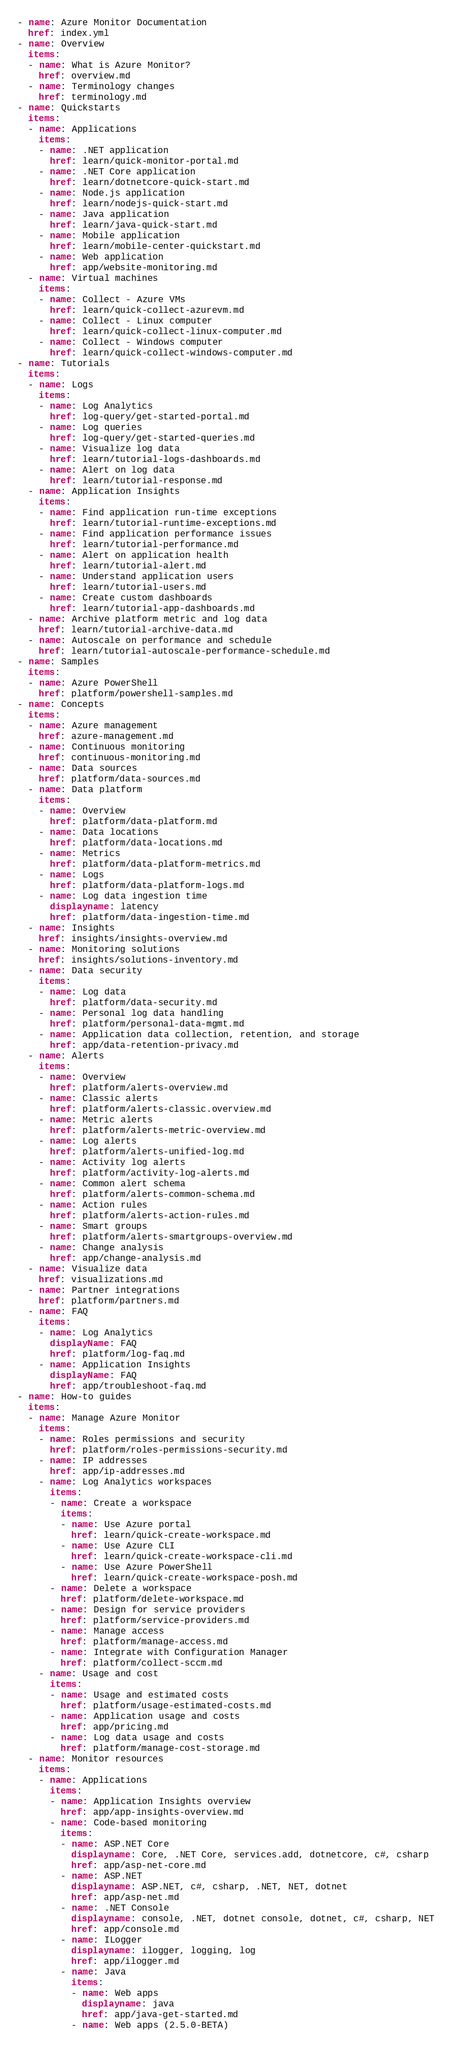Convert code to text. <code><loc_0><loc_0><loc_500><loc_500><_YAML_>- name: Azure Monitor Documentation
  href: index.yml
- name: Overview 
  items:
  - name: What is Azure Monitor?
    href: overview.md
  - name: Terminology changes
    href: terminology.md
- name: Quickstarts
  items:
  - name: Applications
    items:
    - name: .NET application
      href: learn/quick-monitor-portal.md
    - name: .NET Core application
      href: learn/dotnetcore-quick-start.md
    - name: Node.js application
      href: learn/nodejs-quick-start.md
    - name: Java application
      href: learn/java-quick-start.md
    - name: Mobile application
      href: learn/mobile-center-quickstart.md
    - name: Web application
      href: app/website-monitoring.md 
  - name: Virtual machines
    items:
    - name: Collect - Azure VMs
      href: learn/quick-collect-azurevm.md
    - name: Collect - Linux computer
      href: learn/quick-collect-linux-computer.md
    - name: Collect - Windows computer
      href: learn/quick-collect-windows-computer.md
- name: Tutorials
  items:
  - name: Logs
    items: 
    - name: Log Analytics
      href: log-query/get-started-portal.md
    - name: Log queries
      href: log-query/get-started-queries.md
    - name: Visualize log data
      href: learn/tutorial-logs-dashboards.md
    - name: Alert on log data
      href: learn/tutorial-response.md
  - name: Application Insights
    items:  
    - name: Find application run-time exceptions
      href: learn/tutorial-runtime-exceptions.md
    - name: Find application performance issues
      href: learn/tutorial-performance.md
    - name: Alert on application health
      href: learn/tutorial-alert.md
    - name: Understand application users
      href: learn/tutorial-users.md
    - name: Create custom dashboards
      href: learn/tutorial-app-dashboards.md
  - name: Archive platform metric and log data 
    href: learn/tutorial-archive-data.md
  - name: Autoscale on performance and schedule
    href: learn/tutorial-autoscale-performance-schedule.md
- name: Samples
  items:
  - name: Azure PowerShell
    href: platform/powershell-samples.md
- name: Concepts
  items:
  - name: Azure management
    href: azure-management.md
  - name: Continuous monitoring
    href: continuous-monitoring.md
  - name: Data sources
    href: platform/data-sources.md
  - name: Data platform
    items:
    - name: Overview
      href: platform/data-platform.md
    - name: Data locations
      href: platform/data-locations.md
    - name: Metrics
      href: platform/data-platform-metrics.md
    - name: Logs
      href: platform/data-platform-logs.md
    - name: Log data ingestion time
      displayname: latency
      href: platform/data-ingestion-time.md         
  - name: Insights
    href: insights/insights-overview.md
  - name: Monitoring solutions
    href: insights/solutions-inventory.md
  - name: Data security
    items:
    - name: Log data
      href: platform/data-security.md
    - name: Personal log data handling
      href: platform/personal-data-mgmt.md
    - name: Application data collection, retention, and storage
      href: app/data-retention-privacy.md
  - name: Alerts
    items:
    - name: Overview 
      href: platform/alerts-overview.md
    - name: Classic alerts 
      href: platform/alerts-classic.overview.md  
    - name: Metric alerts
      href: platform/alerts-metric-overview.md
    - name: Log alerts
      href: platform/alerts-unified-log.md
    - name: Activity log alerts
      href: platform/activity-log-alerts.md  
    - name: Common alert schema
      href: platform/alerts-common-schema.md
    - name: Action rules
      href: platform/alerts-action-rules.md
    - name: Smart groups
      href: platform/alerts-smartgroups-overview.md 
    - name: Change analysis
      href: app/change-analysis.md 
  - name: Visualize data
    href: visualizations.md
  - name: Partner integrations
    href: platform/partners.md
  - name: FAQ
    items:
    - name: Log Analytics
      displayName: FAQ
      href: platform/log-faq.md
    - name: Application Insights
      displayName: FAQ
      href: app/troubleshoot-faq.md
- name: How-to guides
  items:
  - name: Manage Azure Monitor
    items:
    - name: Roles permissions and security
      href: platform/roles-permissions-security.md
    - name: IP addresses
      href: app/ip-addresses.md
    - name: Log Analytics workspaces
      items:
      - name: Create a workspace
        items:
        - name: Use Azure portal
          href: learn/quick-create-workspace.md 
        - name: Use Azure CLI
          href: learn/quick-create-workspace-cli.md
        - name: Use Azure PowerShell
          href: learn/quick-create-workspace-posh.md
      - name: Delete a workspace
        href: platform/delete-workspace.md
      - name: Design for service providers
        href: platform/service-providers.md
      - name: Manage access
        href: platform/manage-access.md
      - name: Integrate with Configuration Manager
        href: platform/collect-sccm.md
    - name: Usage and cost
      items:
      - name: Usage and estimated costs
        href: platform/usage-estimated-costs.md
      - name: Application usage and costs
        href: app/pricing.md
      - name: Log data usage and costs
        href: platform/manage-cost-storage.md
  - name: Monitor resources
    items:
    - name: Applications
      items:
      - name: Application Insights overview
        href: app/app-insights-overview.md
      - name: Code-based monitoring
        items:
        - name: ASP.NET Core 
          displayname: Core, .NET Core, services.add, dotnetcore, c#, csharp
          href: app/asp-net-core.md
        - name: ASP.NET
          displayname: ASP.NET, c#, csharp, .NET, NET, dotnet 
          href: app/asp-net.md
        - name: .NET Console
          displayname: console, .NET, dotnet console, dotnet, c#, csharp, NET
          href: app/console.md
        - name: ILogger
          displayname: ilogger, logging, log 
          href: app/ilogger.md
        - name: Java
          items:
          - name: Web apps
            displayname: java
            href: app/java-get-started.md
          - name: Web apps (2.5.0-BETA)</code> 